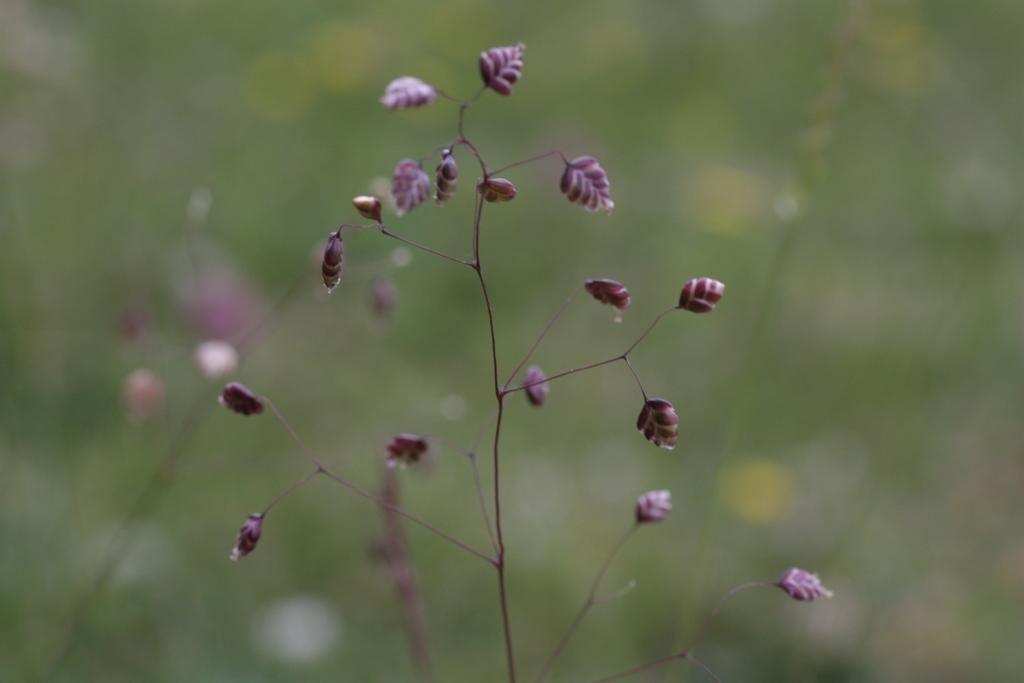What type of living organism can be seen in the image? There is a plant in the image. What color is the van parked next to the plant in the image? There is no van present in the image; it only features a plant. 